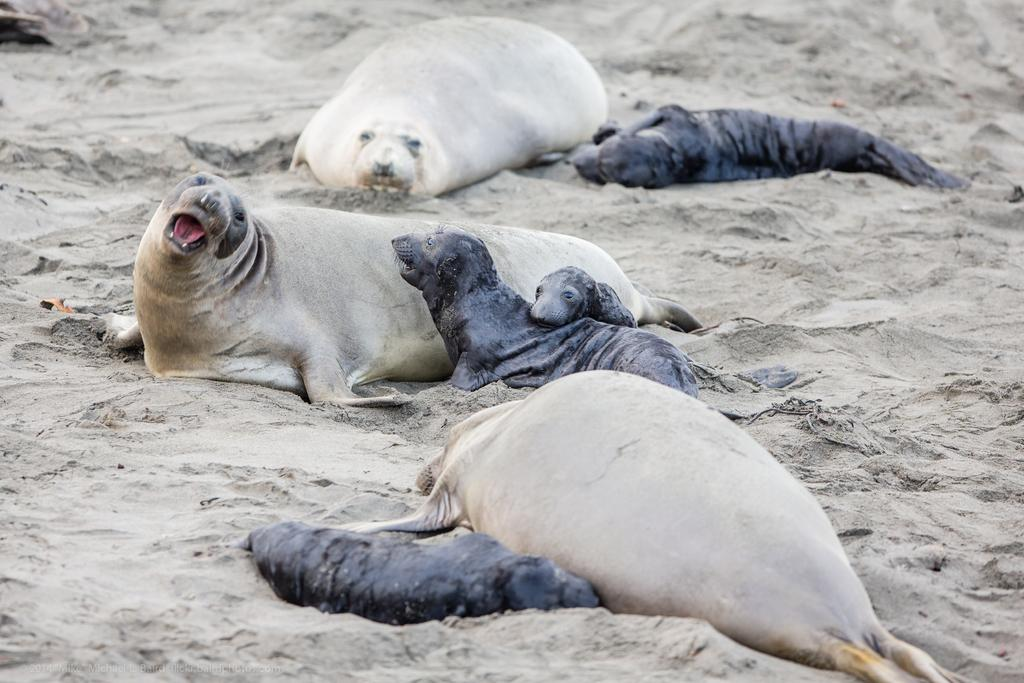What animals can be seen on the ground in the image? There are seals on the ground in the image. What type of terrain is visible in the background of the image? There is sand visible in the background of the image. What type of cart can be seen in the image? There is no cart present in the image. What holiday is being celebrated in the image? The image does not depict a specific holiday. 